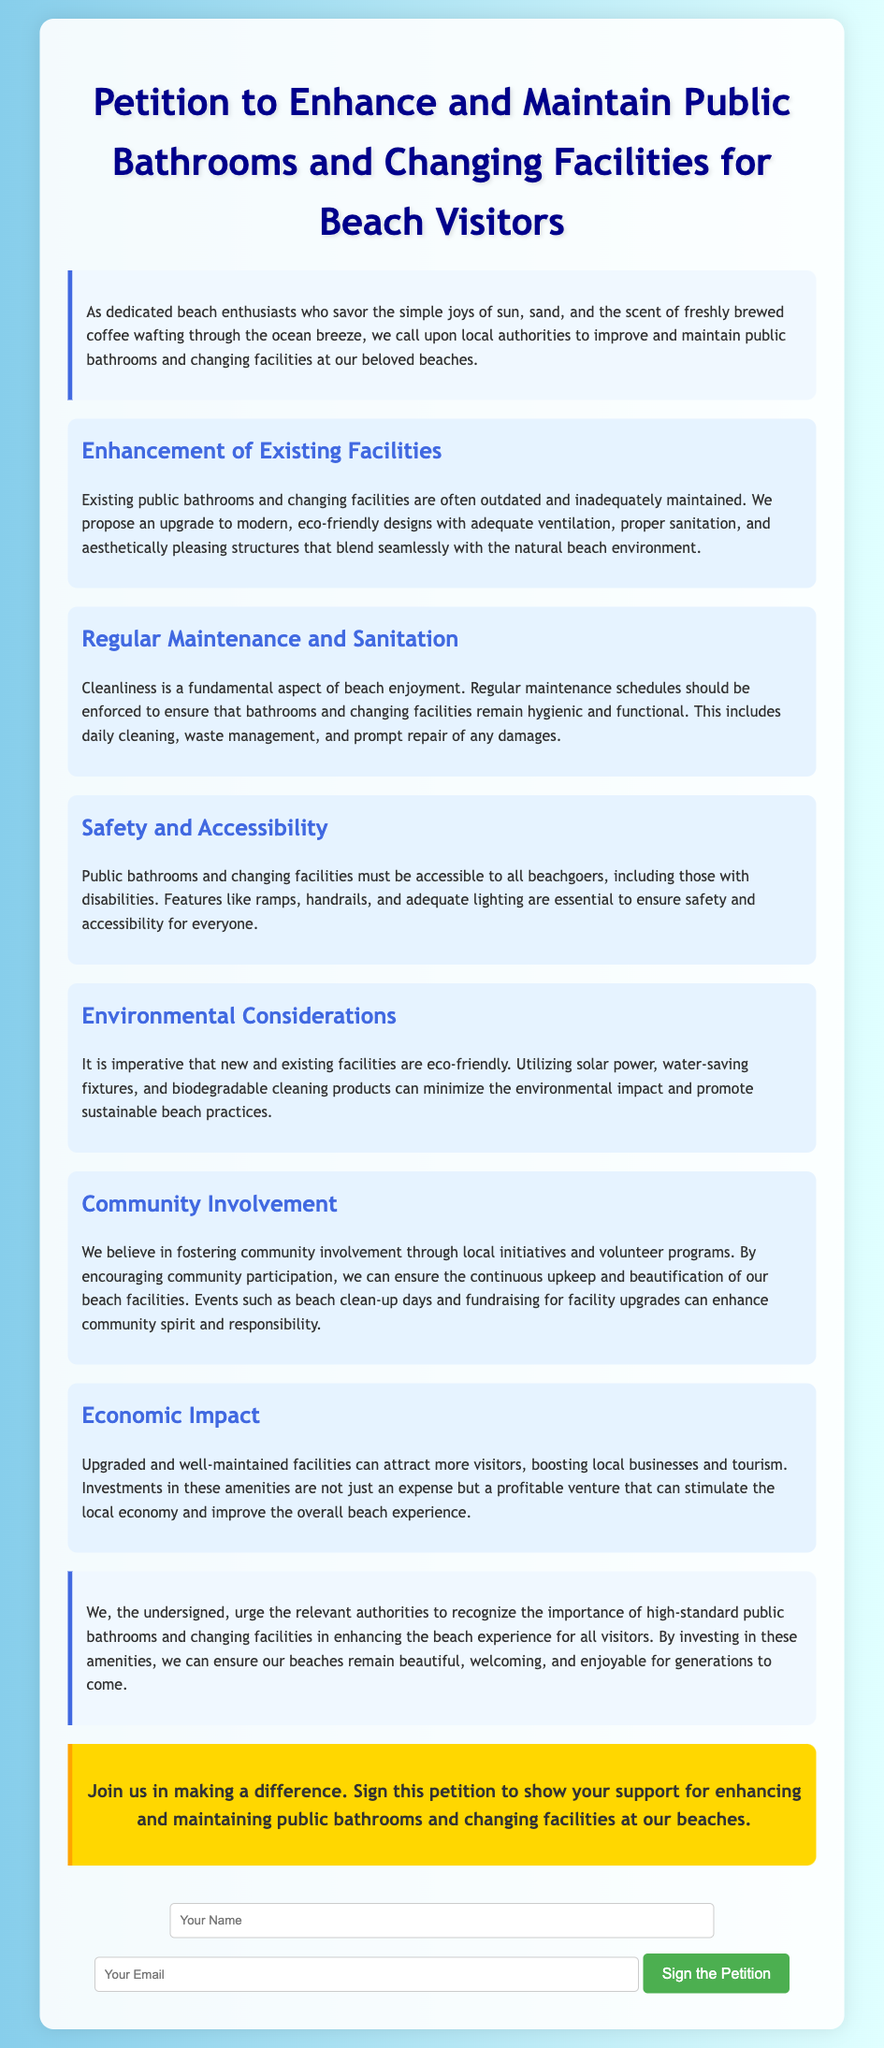What is the title of the petition? The title is presented prominently at the top of the document, stating the purpose of the petition.
Answer: Petition to Enhance and Maintain Public Bathrooms and Changing Facilities for Beach Visitors How many main points are presented in the petition? The petition lists several main points that detail various aspects of enhancing public facilities.
Answer: Six What is proposed for the existing facilities? The petition suggests an upgrade to make the facilities modern and eco-friendly.
Answer: Upgrade to modern, eco-friendly designs What aspect does the "Safety and Accessibility" section highlight? This section emphasizes the importance of making facilities accessible to all beachgoers, including those with disabilities.
Answer: Accessibility to all beachgoers What does the "Environmental Considerations" point suggest using? This point advocates for the use of eco-friendly practices and materials in the facilities.
Answer: Solar power What is the petition urging authorities to recognize? The petition highlights the importance of high-standard facilities for enhancing the beach experience.
Answer: High-standard public bathrooms and changing facilities What community initiative is mentioned in the petition? The petition refers to local efforts to enhance the beach facilities through volunteer programs.
Answer: Beach clean-up days What economic benefit is associated with upgraded facilities? The petition states that improved facilities can attract more visitors and boost local businesses.
Answer: Boosting local businesses and tourism 